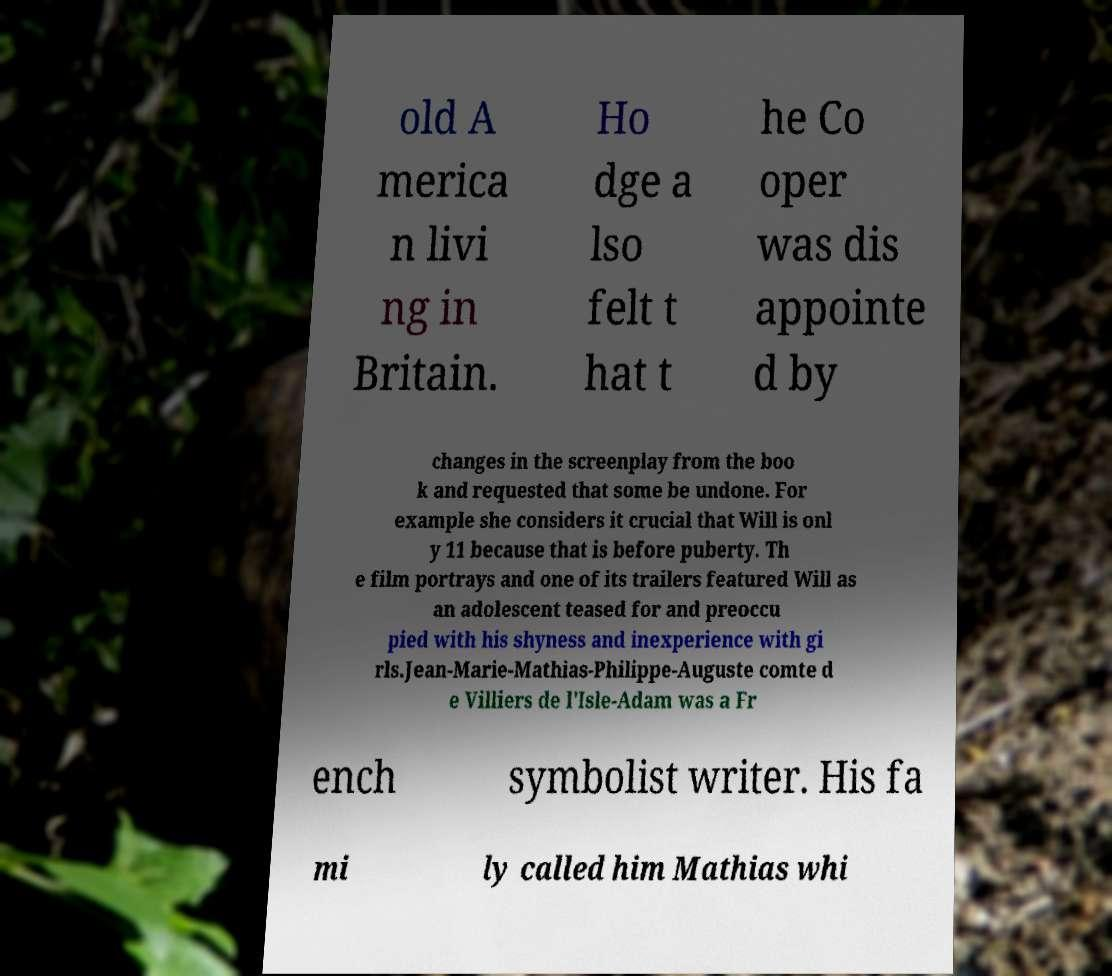I need the written content from this picture converted into text. Can you do that? old A merica n livi ng in Britain. Ho dge a lso felt t hat t he Co oper was dis appointe d by changes in the screenplay from the boo k and requested that some be undone. For example she considers it crucial that Will is onl y 11 because that is before puberty. Th e film portrays and one of its trailers featured Will as an adolescent teased for and preoccu pied with his shyness and inexperience with gi rls.Jean-Marie-Mathias-Philippe-Auguste comte d e Villiers de l'Isle-Adam was a Fr ench symbolist writer. His fa mi ly called him Mathias whi 